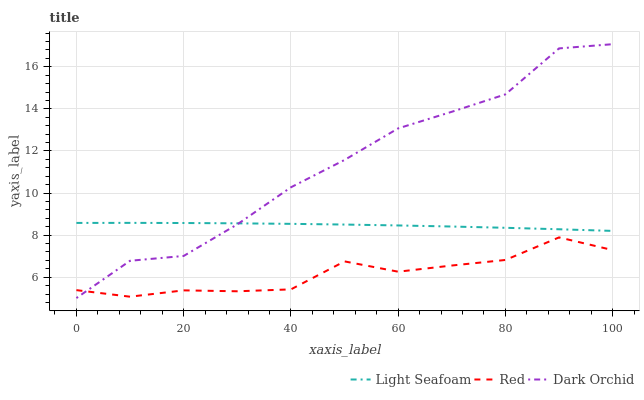Does Red have the minimum area under the curve?
Answer yes or no. Yes. Does Dark Orchid have the maximum area under the curve?
Answer yes or no. Yes. Does Dark Orchid have the minimum area under the curve?
Answer yes or no. No. Does Red have the maximum area under the curve?
Answer yes or no. No. Is Light Seafoam the smoothest?
Answer yes or no. Yes. Is Dark Orchid the roughest?
Answer yes or no. Yes. Is Red the smoothest?
Answer yes or no. No. Is Red the roughest?
Answer yes or no. No. Does Dark Orchid have the lowest value?
Answer yes or no. Yes. Does Red have the lowest value?
Answer yes or no. No. Does Dark Orchid have the highest value?
Answer yes or no. Yes. Does Red have the highest value?
Answer yes or no. No. Is Red less than Light Seafoam?
Answer yes or no. Yes. Is Light Seafoam greater than Red?
Answer yes or no. Yes. Does Dark Orchid intersect Red?
Answer yes or no. Yes. Is Dark Orchid less than Red?
Answer yes or no. No. Is Dark Orchid greater than Red?
Answer yes or no. No. Does Red intersect Light Seafoam?
Answer yes or no. No. 